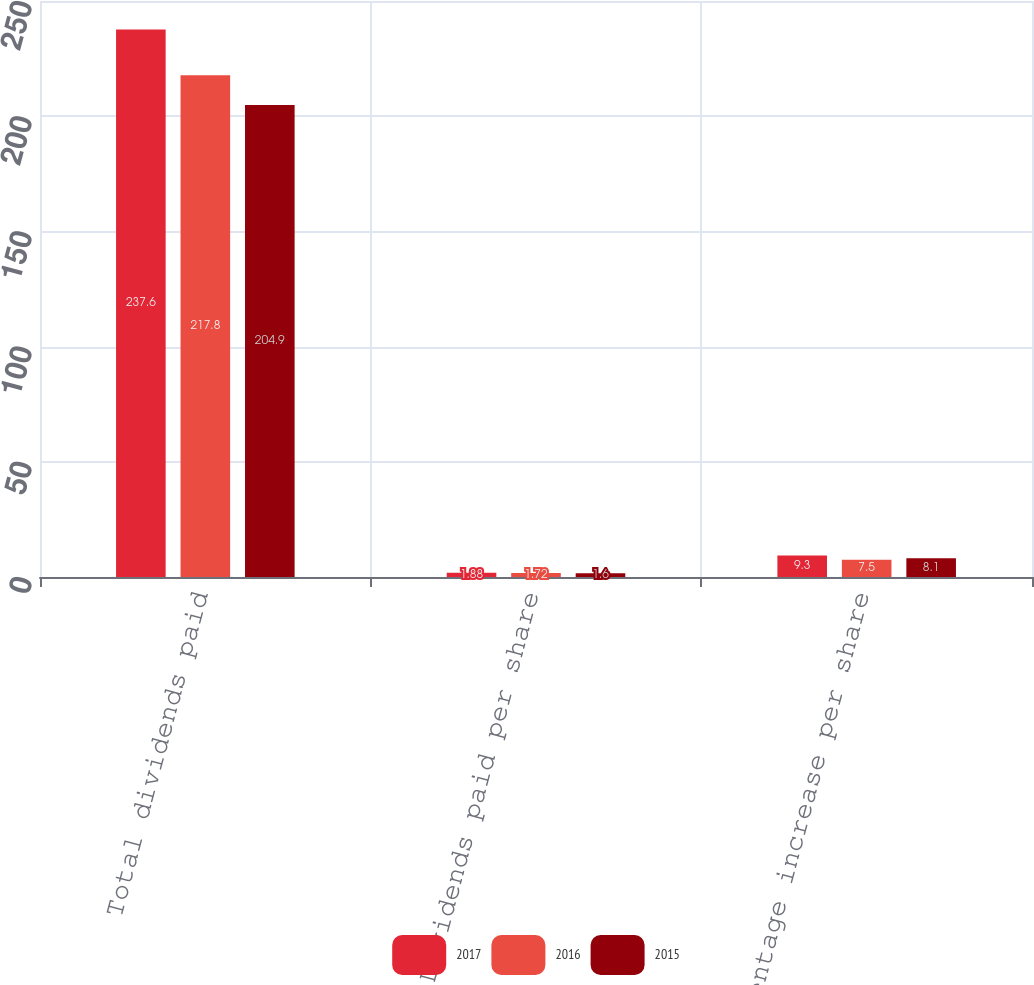Convert chart. <chart><loc_0><loc_0><loc_500><loc_500><stacked_bar_chart><ecel><fcel>Total dividends paid<fcel>Dividends paid per share<fcel>Percentage increase per share<nl><fcel>2017<fcel>237.6<fcel>1.88<fcel>9.3<nl><fcel>2016<fcel>217.8<fcel>1.72<fcel>7.5<nl><fcel>2015<fcel>204.9<fcel>1.6<fcel>8.1<nl></chart> 